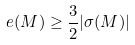Convert formula to latex. <formula><loc_0><loc_0><loc_500><loc_500>e ( M ) \geq \frac { 3 } { 2 } | \sigma ( M ) |</formula> 